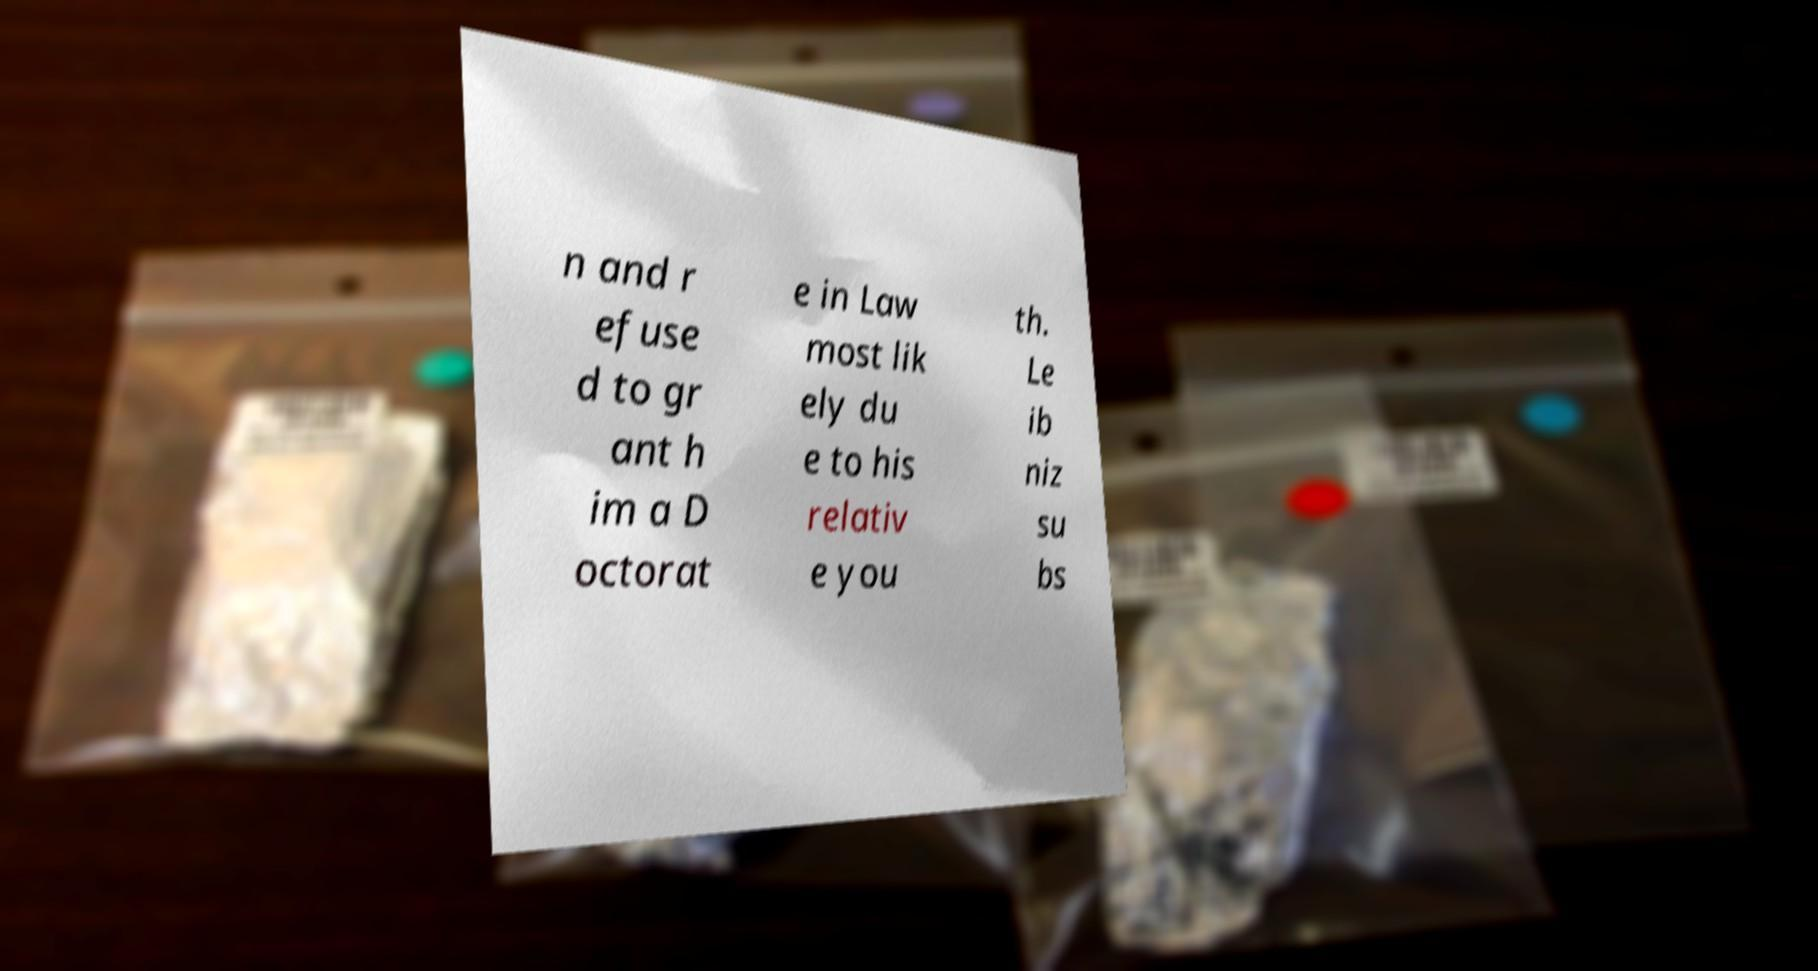I need the written content from this picture converted into text. Can you do that? n and r efuse d to gr ant h im a D octorat e in Law most lik ely du e to his relativ e you th. Le ib niz su bs 